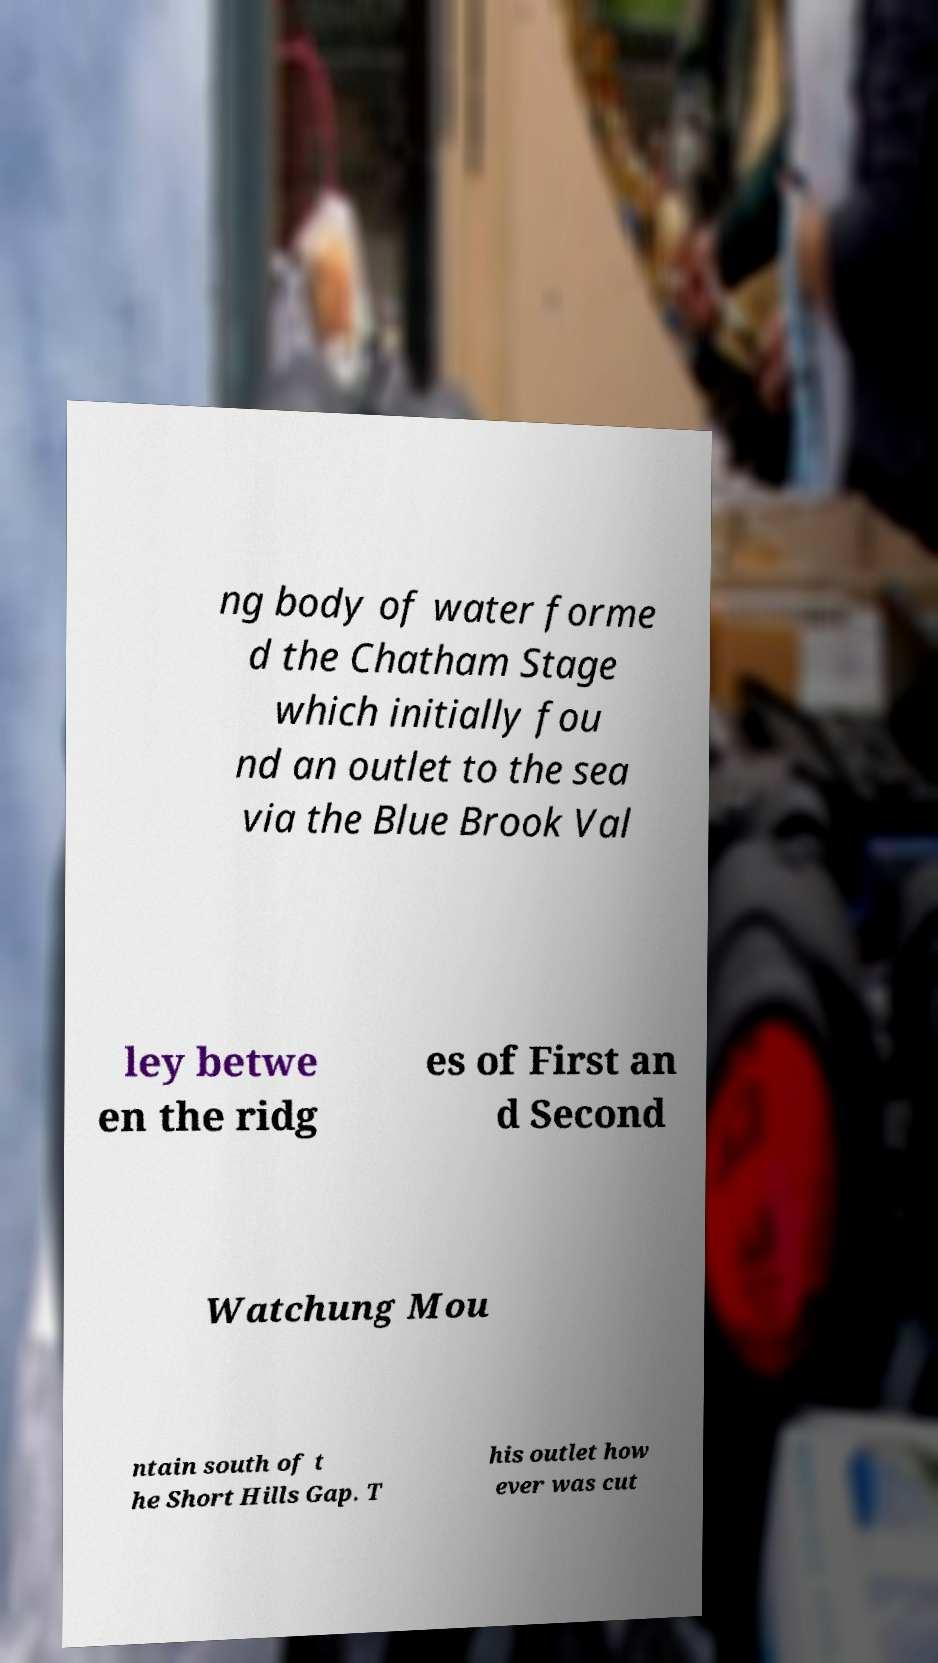Can you accurately transcribe the text from the provided image for me? ng body of water forme d the Chatham Stage which initially fou nd an outlet to the sea via the Blue Brook Val ley betwe en the ridg es of First an d Second Watchung Mou ntain south of t he Short Hills Gap. T his outlet how ever was cut 